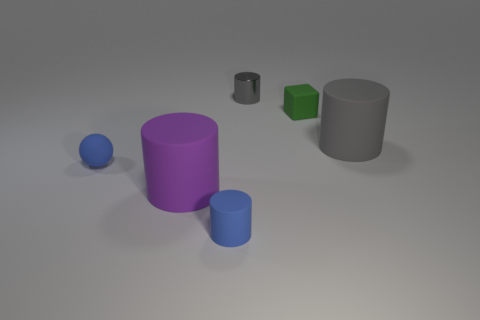There is a large object that is left of the small gray cylinder; what is its shape?
Provide a short and direct response. Cylinder. What color is the cylinder that is to the right of the gray thing behind the big cylinder that is behind the big purple object?
Keep it short and to the point. Gray. The big purple thing that is the same material as the block is what shape?
Make the answer very short. Cylinder. Are there fewer tiny rubber objects than small metallic cylinders?
Offer a terse response. No. Are the block and the purple cylinder made of the same material?
Provide a short and direct response. Yes. How many other objects are the same color as the tiny metallic object?
Make the answer very short. 1. Are there more tiny green matte objects than big gray matte balls?
Keep it short and to the point. Yes. Is the size of the green thing the same as the matte cylinder behind the blue rubber sphere?
Provide a succinct answer. No. What is the color of the big matte cylinder that is to the right of the large purple cylinder?
Keep it short and to the point. Gray. What number of cyan objects are either small blocks or tiny shiny spheres?
Provide a succinct answer. 0. 